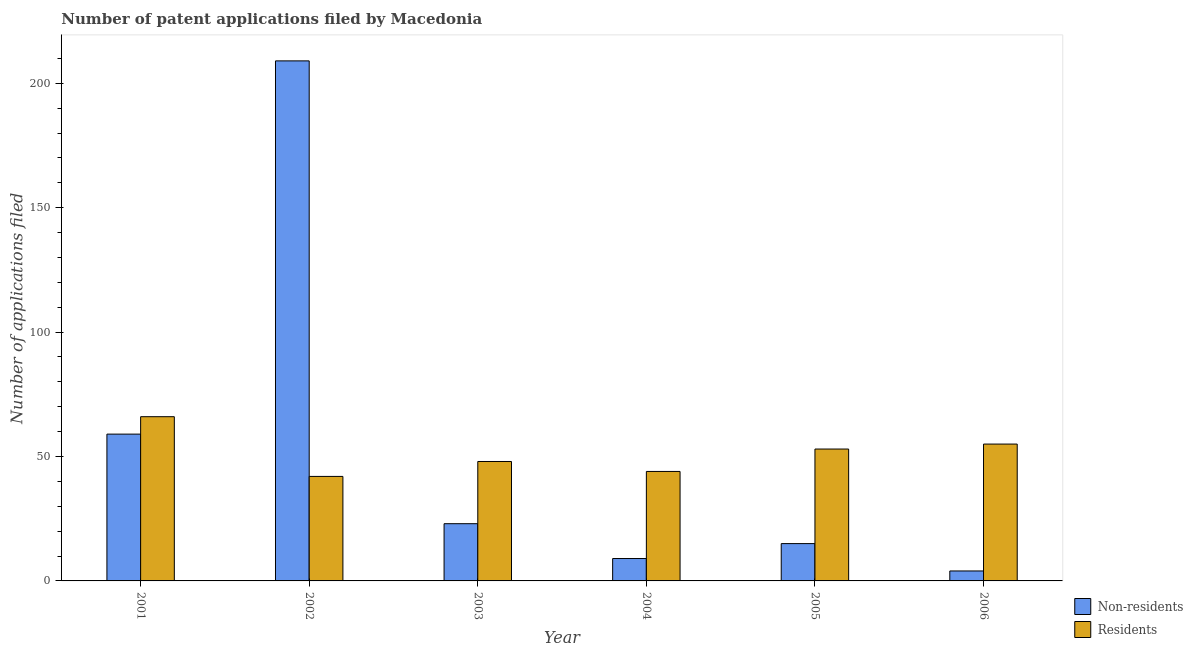Are the number of bars per tick equal to the number of legend labels?
Ensure brevity in your answer.  Yes. How many bars are there on the 4th tick from the left?
Your response must be concise. 2. What is the number of patent applications by residents in 2004?
Your answer should be very brief. 44. Across all years, what is the maximum number of patent applications by non residents?
Ensure brevity in your answer.  209. Across all years, what is the minimum number of patent applications by non residents?
Keep it short and to the point. 4. What is the total number of patent applications by residents in the graph?
Keep it short and to the point. 308. What is the difference between the number of patent applications by non residents in 2002 and that in 2006?
Provide a short and direct response. 205. What is the difference between the number of patent applications by non residents in 2003 and the number of patent applications by residents in 2005?
Offer a very short reply. 8. What is the average number of patent applications by non residents per year?
Offer a very short reply. 53.17. In the year 2004, what is the difference between the number of patent applications by non residents and number of patent applications by residents?
Ensure brevity in your answer.  0. In how many years, is the number of patent applications by residents greater than 80?
Provide a succinct answer. 0. What is the ratio of the number of patent applications by residents in 2002 to that in 2003?
Make the answer very short. 0.88. Is the difference between the number of patent applications by non residents in 2001 and 2005 greater than the difference between the number of patent applications by residents in 2001 and 2005?
Offer a terse response. No. What is the difference between the highest and the second highest number of patent applications by non residents?
Your answer should be compact. 150. What is the difference between the highest and the lowest number of patent applications by non residents?
Provide a short and direct response. 205. In how many years, is the number of patent applications by non residents greater than the average number of patent applications by non residents taken over all years?
Give a very brief answer. 2. What does the 2nd bar from the left in 2006 represents?
Your answer should be very brief. Residents. What does the 2nd bar from the right in 2001 represents?
Offer a terse response. Non-residents. How many bars are there?
Your response must be concise. 12. How many years are there in the graph?
Offer a terse response. 6. What is the difference between two consecutive major ticks on the Y-axis?
Make the answer very short. 50. Does the graph contain any zero values?
Give a very brief answer. No. How are the legend labels stacked?
Offer a terse response. Vertical. What is the title of the graph?
Your response must be concise. Number of patent applications filed by Macedonia. Does "GDP" appear as one of the legend labels in the graph?
Provide a short and direct response. No. What is the label or title of the Y-axis?
Make the answer very short. Number of applications filed. What is the Number of applications filed in Non-residents in 2002?
Your answer should be compact. 209. What is the Number of applications filed of Non-residents in 2004?
Provide a short and direct response. 9. What is the Number of applications filed in Non-residents in 2005?
Provide a succinct answer. 15. What is the Number of applications filed of Residents in 2005?
Your answer should be very brief. 53. What is the Number of applications filed in Non-residents in 2006?
Offer a terse response. 4. What is the Number of applications filed in Residents in 2006?
Offer a very short reply. 55. Across all years, what is the maximum Number of applications filed of Non-residents?
Give a very brief answer. 209. Across all years, what is the maximum Number of applications filed of Residents?
Your answer should be compact. 66. Across all years, what is the minimum Number of applications filed in Non-residents?
Provide a succinct answer. 4. Across all years, what is the minimum Number of applications filed in Residents?
Your answer should be compact. 42. What is the total Number of applications filed of Non-residents in the graph?
Your answer should be very brief. 319. What is the total Number of applications filed of Residents in the graph?
Ensure brevity in your answer.  308. What is the difference between the Number of applications filed in Non-residents in 2001 and that in 2002?
Offer a terse response. -150. What is the difference between the Number of applications filed of Residents in 2001 and that in 2002?
Ensure brevity in your answer.  24. What is the difference between the Number of applications filed of Residents in 2001 and that in 2003?
Give a very brief answer. 18. What is the difference between the Number of applications filed in Non-residents in 2001 and that in 2004?
Make the answer very short. 50. What is the difference between the Number of applications filed of Residents in 2001 and that in 2004?
Keep it short and to the point. 22. What is the difference between the Number of applications filed of Non-residents in 2001 and that in 2005?
Provide a short and direct response. 44. What is the difference between the Number of applications filed in Non-residents in 2001 and that in 2006?
Your answer should be very brief. 55. What is the difference between the Number of applications filed in Non-residents in 2002 and that in 2003?
Offer a very short reply. 186. What is the difference between the Number of applications filed of Residents in 2002 and that in 2004?
Keep it short and to the point. -2. What is the difference between the Number of applications filed of Non-residents in 2002 and that in 2005?
Make the answer very short. 194. What is the difference between the Number of applications filed in Residents in 2002 and that in 2005?
Give a very brief answer. -11. What is the difference between the Number of applications filed in Non-residents in 2002 and that in 2006?
Provide a short and direct response. 205. What is the difference between the Number of applications filed of Residents in 2002 and that in 2006?
Keep it short and to the point. -13. What is the difference between the Number of applications filed of Non-residents in 2003 and that in 2004?
Give a very brief answer. 14. What is the difference between the Number of applications filed in Residents in 2003 and that in 2004?
Keep it short and to the point. 4. What is the difference between the Number of applications filed of Non-residents in 2003 and that in 2005?
Your response must be concise. 8. What is the difference between the Number of applications filed of Residents in 2003 and that in 2005?
Ensure brevity in your answer.  -5. What is the difference between the Number of applications filed in Non-residents in 2003 and that in 2006?
Keep it short and to the point. 19. What is the difference between the Number of applications filed of Residents in 2004 and that in 2005?
Your answer should be very brief. -9. What is the difference between the Number of applications filed of Residents in 2005 and that in 2006?
Make the answer very short. -2. What is the difference between the Number of applications filed in Non-residents in 2001 and the Number of applications filed in Residents in 2004?
Give a very brief answer. 15. What is the difference between the Number of applications filed in Non-residents in 2001 and the Number of applications filed in Residents in 2006?
Ensure brevity in your answer.  4. What is the difference between the Number of applications filed of Non-residents in 2002 and the Number of applications filed of Residents in 2003?
Keep it short and to the point. 161. What is the difference between the Number of applications filed of Non-residents in 2002 and the Number of applications filed of Residents in 2004?
Give a very brief answer. 165. What is the difference between the Number of applications filed of Non-residents in 2002 and the Number of applications filed of Residents in 2005?
Offer a very short reply. 156. What is the difference between the Number of applications filed of Non-residents in 2002 and the Number of applications filed of Residents in 2006?
Provide a short and direct response. 154. What is the difference between the Number of applications filed in Non-residents in 2003 and the Number of applications filed in Residents in 2006?
Make the answer very short. -32. What is the difference between the Number of applications filed of Non-residents in 2004 and the Number of applications filed of Residents in 2005?
Your answer should be compact. -44. What is the difference between the Number of applications filed of Non-residents in 2004 and the Number of applications filed of Residents in 2006?
Ensure brevity in your answer.  -46. What is the difference between the Number of applications filed in Non-residents in 2005 and the Number of applications filed in Residents in 2006?
Ensure brevity in your answer.  -40. What is the average Number of applications filed of Non-residents per year?
Provide a succinct answer. 53.17. What is the average Number of applications filed of Residents per year?
Your answer should be compact. 51.33. In the year 2001, what is the difference between the Number of applications filed in Non-residents and Number of applications filed in Residents?
Your response must be concise. -7. In the year 2002, what is the difference between the Number of applications filed of Non-residents and Number of applications filed of Residents?
Ensure brevity in your answer.  167. In the year 2004, what is the difference between the Number of applications filed in Non-residents and Number of applications filed in Residents?
Offer a terse response. -35. In the year 2005, what is the difference between the Number of applications filed of Non-residents and Number of applications filed of Residents?
Offer a terse response. -38. In the year 2006, what is the difference between the Number of applications filed in Non-residents and Number of applications filed in Residents?
Provide a succinct answer. -51. What is the ratio of the Number of applications filed in Non-residents in 2001 to that in 2002?
Keep it short and to the point. 0.28. What is the ratio of the Number of applications filed in Residents in 2001 to that in 2002?
Give a very brief answer. 1.57. What is the ratio of the Number of applications filed in Non-residents in 2001 to that in 2003?
Make the answer very short. 2.57. What is the ratio of the Number of applications filed in Residents in 2001 to that in 2003?
Your response must be concise. 1.38. What is the ratio of the Number of applications filed in Non-residents in 2001 to that in 2004?
Offer a very short reply. 6.56. What is the ratio of the Number of applications filed in Residents in 2001 to that in 2004?
Provide a succinct answer. 1.5. What is the ratio of the Number of applications filed in Non-residents in 2001 to that in 2005?
Keep it short and to the point. 3.93. What is the ratio of the Number of applications filed of Residents in 2001 to that in 2005?
Provide a short and direct response. 1.25. What is the ratio of the Number of applications filed of Non-residents in 2001 to that in 2006?
Provide a succinct answer. 14.75. What is the ratio of the Number of applications filed in Non-residents in 2002 to that in 2003?
Ensure brevity in your answer.  9.09. What is the ratio of the Number of applications filed in Non-residents in 2002 to that in 2004?
Your answer should be compact. 23.22. What is the ratio of the Number of applications filed of Residents in 2002 to that in 2004?
Offer a very short reply. 0.95. What is the ratio of the Number of applications filed in Non-residents in 2002 to that in 2005?
Offer a terse response. 13.93. What is the ratio of the Number of applications filed of Residents in 2002 to that in 2005?
Offer a terse response. 0.79. What is the ratio of the Number of applications filed of Non-residents in 2002 to that in 2006?
Provide a succinct answer. 52.25. What is the ratio of the Number of applications filed of Residents in 2002 to that in 2006?
Make the answer very short. 0.76. What is the ratio of the Number of applications filed in Non-residents in 2003 to that in 2004?
Keep it short and to the point. 2.56. What is the ratio of the Number of applications filed in Non-residents in 2003 to that in 2005?
Provide a short and direct response. 1.53. What is the ratio of the Number of applications filed in Residents in 2003 to that in 2005?
Provide a short and direct response. 0.91. What is the ratio of the Number of applications filed in Non-residents in 2003 to that in 2006?
Ensure brevity in your answer.  5.75. What is the ratio of the Number of applications filed of Residents in 2003 to that in 2006?
Offer a terse response. 0.87. What is the ratio of the Number of applications filed in Residents in 2004 to that in 2005?
Make the answer very short. 0.83. What is the ratio of the Number of applications filed of Non-residents in 2004 to that in 2006?
Offer a very short reply. 2.25. What is the ratio of the Number of applications filed in Residents in 2004 to that in 2006?
Your answer should be very brief. 0.8. What is the ratio of the Number of applications filed of Non-residents in 2005 to that in 2006?
Ensure brevity in your answer.  3.75. What is the ratio of the Number of applications filed of Residents in 2005 to that in 2006?
Your response must be concise. 0.96. What is the difference between the highest and the second highest Number of applications filed of Non-residents?
Give a very brief answer. 150. What is the difference between the highest and the lowest Number of applications filed of Non-residents?
Provide a succinct answer. 205. What is the difference between the highest and the lowest Number of applications filed of Residents?
Give a very brief answer. 24. 